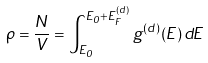<formula> <loc_0><loc_0><loc_500><loc_500>\rho = { \frac { N } { V } } = \int _ { E _ { 0 } } ^ { E _ { 0 } + E _ { F } ^ { ( d ) } } g ^ { ( d ) } ( E ) \, d E</formula> 